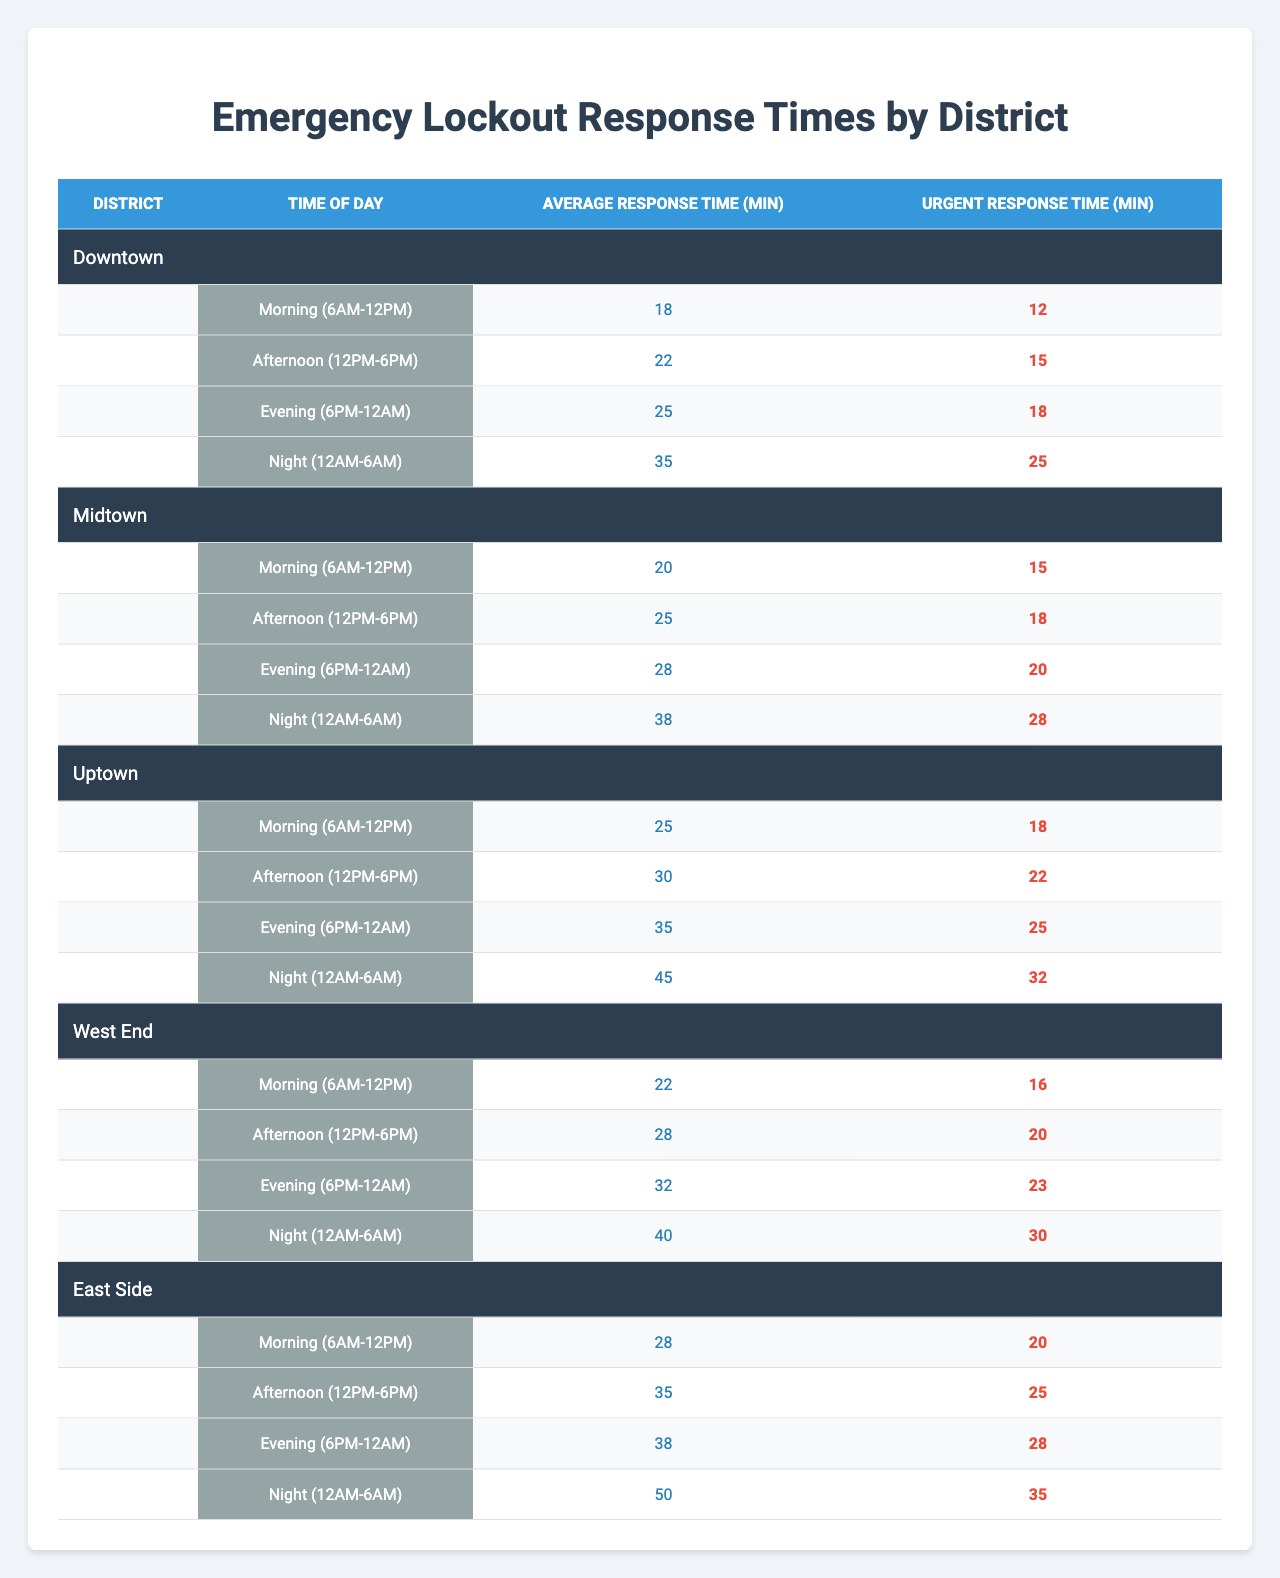What's the average response time for lockouts in the Downtown district during the evening? The average response time for the evening in the Downtown district is 25 minutes, as indicated in the table.
Answer: 25 minutes Which district has the shortest urgent response time during the afternoon? In the afternoon, the urgent response times for each district are: Downtown (15), Midtown (18), Uptown (22), West End (20), and East Side (25). Downtown has the shortest urgent response time of 15 minutes.
Answer: Downtown What is the difference between the average response time during the night and the afternoon for the UPTOWN district? The average response time for Uptown during the night is 45 minutes, and during the afternoon, it is 30 minutes. The difference is 45 - 30 = 15 minutes.
Answer: 15 minutes True or False: The East Side district has the longest average response time during the night. The average response time for the night in East Side is 50 minutes, which is the highest among all districts (Downtown 35, Midtown 38, Uptown 45, West End 40). Therefore, this statement is true.
Answer: True What is the average urgent response time across all districts during the morning? The urgent response times during the morning for each district are: Downtown (12), Midtown (15), Uptown (18), West End (16), and East Side (20). The total is 12 + 15 + 18 + 16 + 20 = 81. There are 5 districts, so the average is 81/5 = 16.2 minutes.
Answer: 16.2 minutes Which district shows the greatest increase in average response time from morning to night? Checking the average response times for each district: Downtown increases from 18 (morning) to 35 (night), Midtown from 20 to 38, Uptown from 25 to 45, West End from 22 to 40, and East Side from 28 to 50. Uptown shows the greatest increase: 45 - 25 = 20 minutes.
Answer: Uptown What is the total urgent response time for the West End district across all time periods? The urgent response times for West End are: Morning (16), Afternoon (20), Evening (23), Night (30). Adding them up gives 16 + 20 + 23 + 30 = 89 minutes.
Answer: 89 minutes How does the average response time for Downtown in the evening compare to East Side during the same time? The average response time for Downtown in the evening is 25 minutes, while for East Side it is 38 minutes. Comparing these shows that East Side takes 13 minutes longer than Downtown.
Answer: 13 minutes longer Which time of day has the highest average response time across all districts? The highest average response times are: Morning (average of 21.8), Afternoon (average of 26), Evening (average of 29.6), Night (average of 39.6). The night has the highest average response time: 39.6 minutes.
Answer: Night Is the urgent response time during the night for Midtown higher than the average for the afternoon in any other district? The urgent response time for Midtown during the night is 28 minutes. In the afternoon, the urgent times are: Downtown (15), Midtown (18), Uptown (22), West End (20), East Side (25). Since 28 is greater than 25, which is the max in the afternoon, this statement is correct.
Answer: Yes 